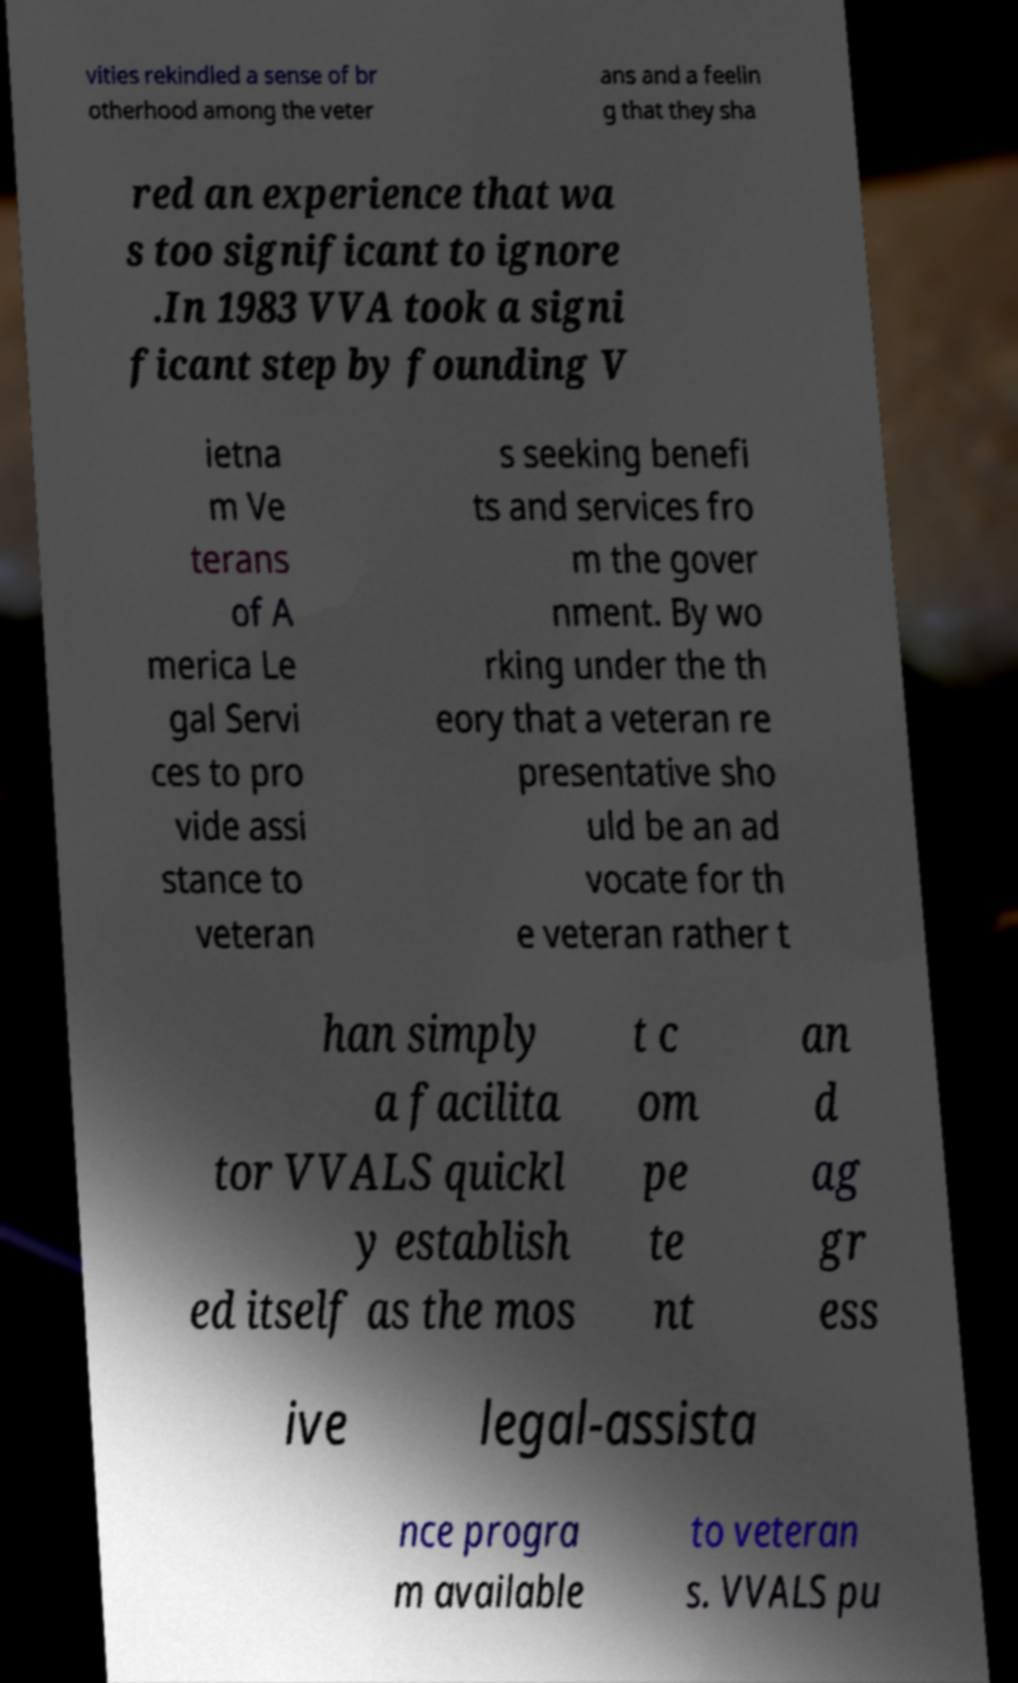Could you extract and type out the text from this image? vities rekindled a sense of br otherhood among the veter ans and a feelin g that they sha red an experience that wa s too significant to ignore .In 1983 VVA took a signi ficant step by founding V ietna m Ve terans of A merica Le gal Servi ces to pro vide assi stance to veteran s seeking benefi ts and services fro m the gover nment. By wo rking under the th eory that a veteran re presentative sho uld be an ad vocate for th e veteran rather t han simply a facilita tor VVALS quickl y establish ed itself as the mos t c om pe te nt an d ag gr ess ive legal-assista nce progra m available to veteran s. VVALS pu 